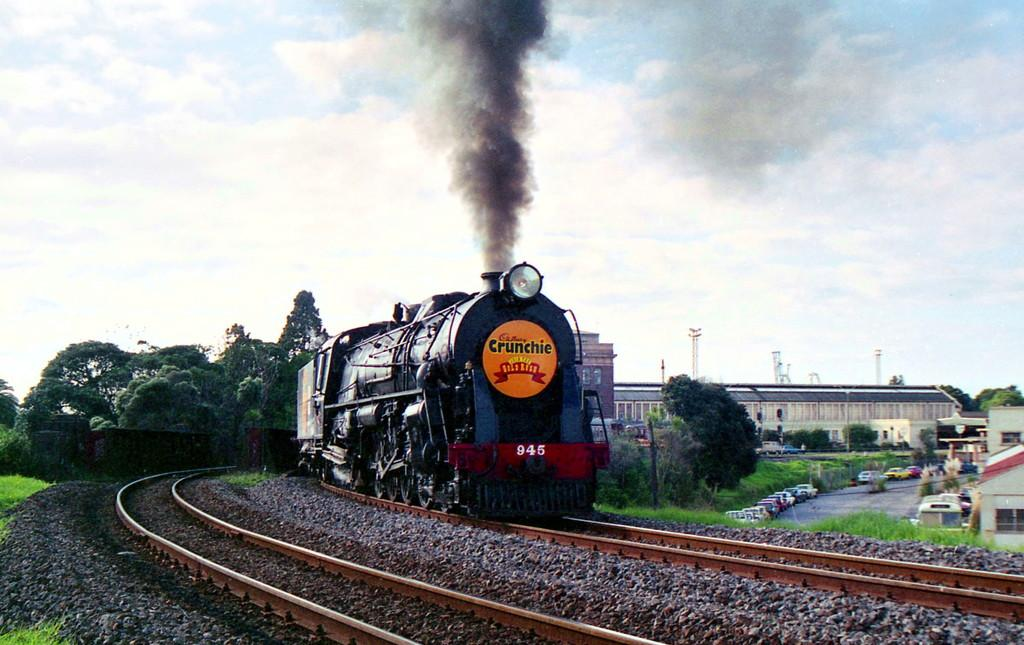What mode of transportation can be seen on the track in the image? There is a train on the track in the image. What type of vegetation is visible in the image? There is grass visible in the image. What else can be seen on the ground besides the train? There are vehicles on the road in the image. What type of natural structures are present in the image? Trees are present in the image. What type of man-made structures can be seen in the image? Poles and buildings are visible in the image. What is the weather like in the image? The sky is visible in the background, and clouds are present in the sky, suggesting a partly cloudy day. What is the train emitting in the image? There is smoke in the image. What type of zipper can be seen on the train in the image? There are no zippers present on the train in the image. What is the opinion of the trees about the train in the image? Trees do not have opinions, as they are inanimate objects. 